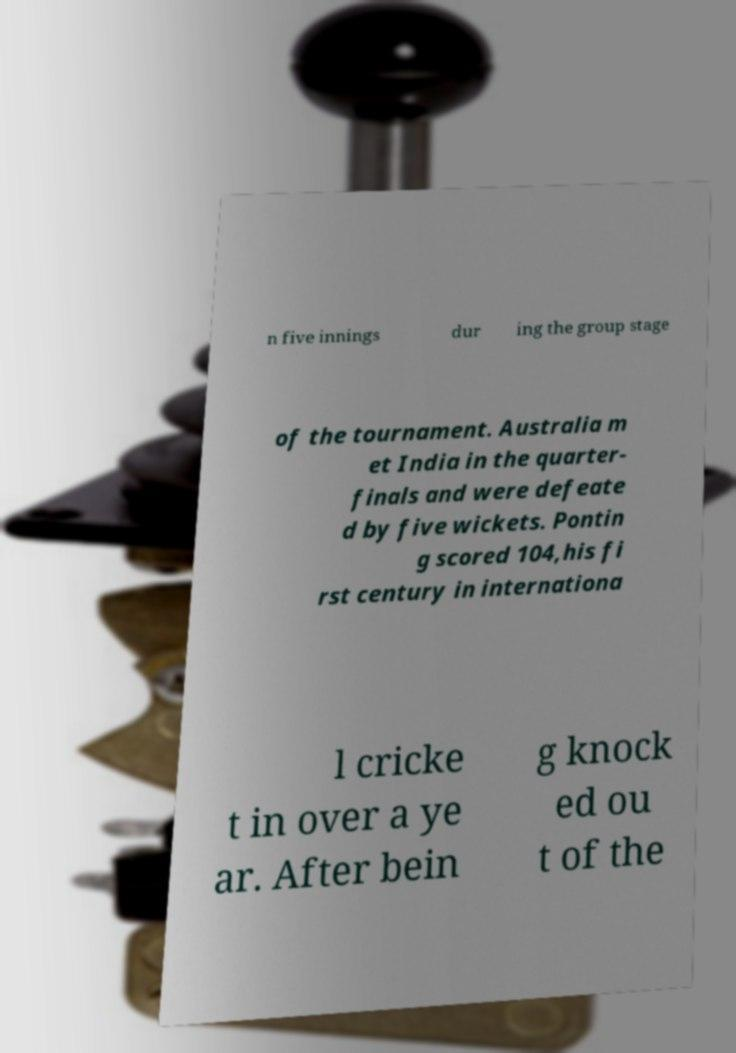Can you read and provide the text displayed in the image?This photo seems to have some interesting text. Can you extract and type it out for me? n five innings dur ing the group stage of the tournament. Australia m et India in the quarter- finals and were defeate d by five wickets. Pontin g scored 104,his fi rst century in internationa l cricke t in over a ye ar. After bein g knock ed ou t of the 